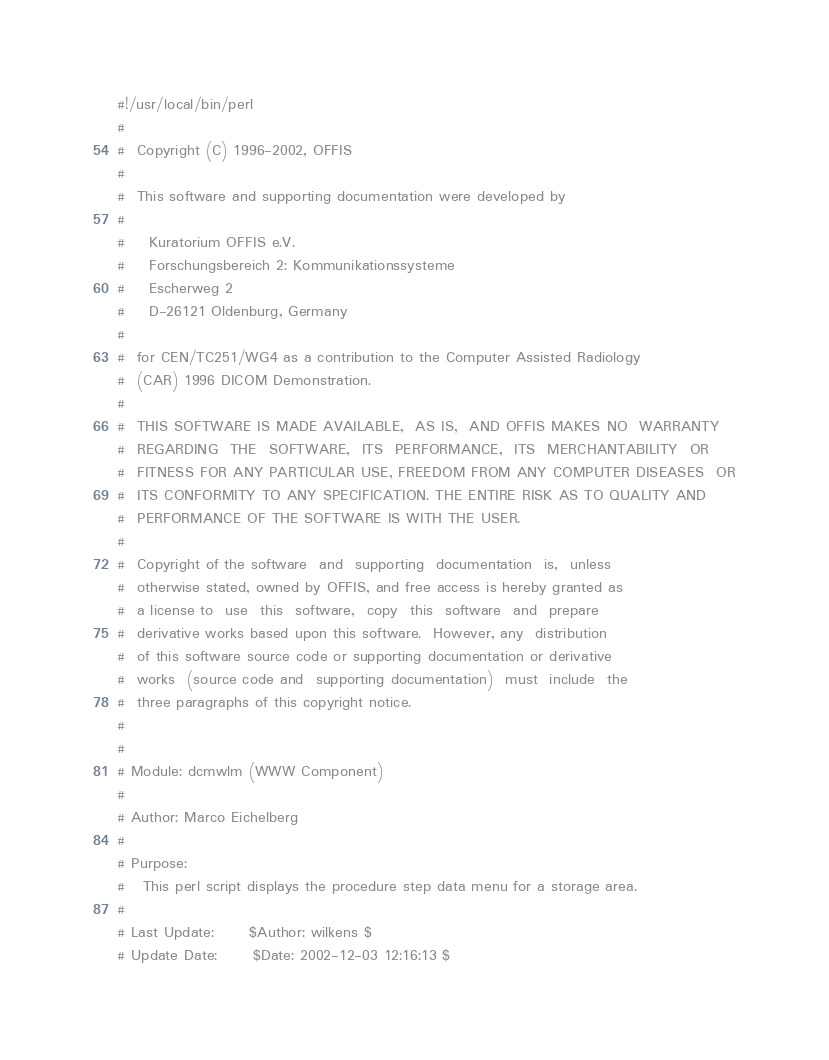Convert code to text. <code><loc_0><loc_0><loc_500><loc_500><_Perl_>#!/usr/local/bin/perl
#
#  Copyright (C) 1996-2002, OFFIS
#
#  This software and supporting documentation were developed by
#
#    Kuratorium OFFIS e.V.
#    Forschungsbereich 2: Kommunikationssysteme
#    Escherweg 2
#    D-26121 Oldenburg, Germany
#
#  for CEN/TC251/WG4 as a contribution to the Computer Assisted Radiology
#  (CAR) 1996 DICOM Demonstration.
#
#  THIS SOFTWARE IS MADE AVAILABLE,  AS IS,  AND OFFIS MAKES NO  WARRANTY
#  REGARDING  THE  SOFTWARE,  ITS  PERFORMANCE,  ITS  MERCHANTABILITY  OR
#  FITNESS FOR ANY PARTICULAR USE, FREEDOM FROM ANY COMPUTER DISEASES  OR
#  ITS CONFORMITY TO ANY SPECIFICATION. THE ENTIRE RISK AS TO QUALITY AND
#  PERFORMANCE OF THE SOFTWARE IS WITH THE USER.
#
#  Copyright of the software  and  supporting  documentation  is,  unless
#  otherwise stated, owned by OFFIS, and free access is hereby granted as
#  a license to  use  this  software,  copy  this  software  and  prepare
#  derivative works based upon this software.  However, any  distribution
#  of this software source code or supporting documentation or derivative
#  works  (source code and  supporting documentation)  must  include  the
#  three paragraphs of this copyright notice.
#
#
# Module: dcmwlm (WWW Component)
#
# Author: Marco Eichelberg
#
# Purpose:
#   This perl script displays the procedure step data menu for a storage area.
#
# Last Update:      $Author: wilkens $
# Update Date:      $Date: 2002-12-03 12:16:13 $</code> 